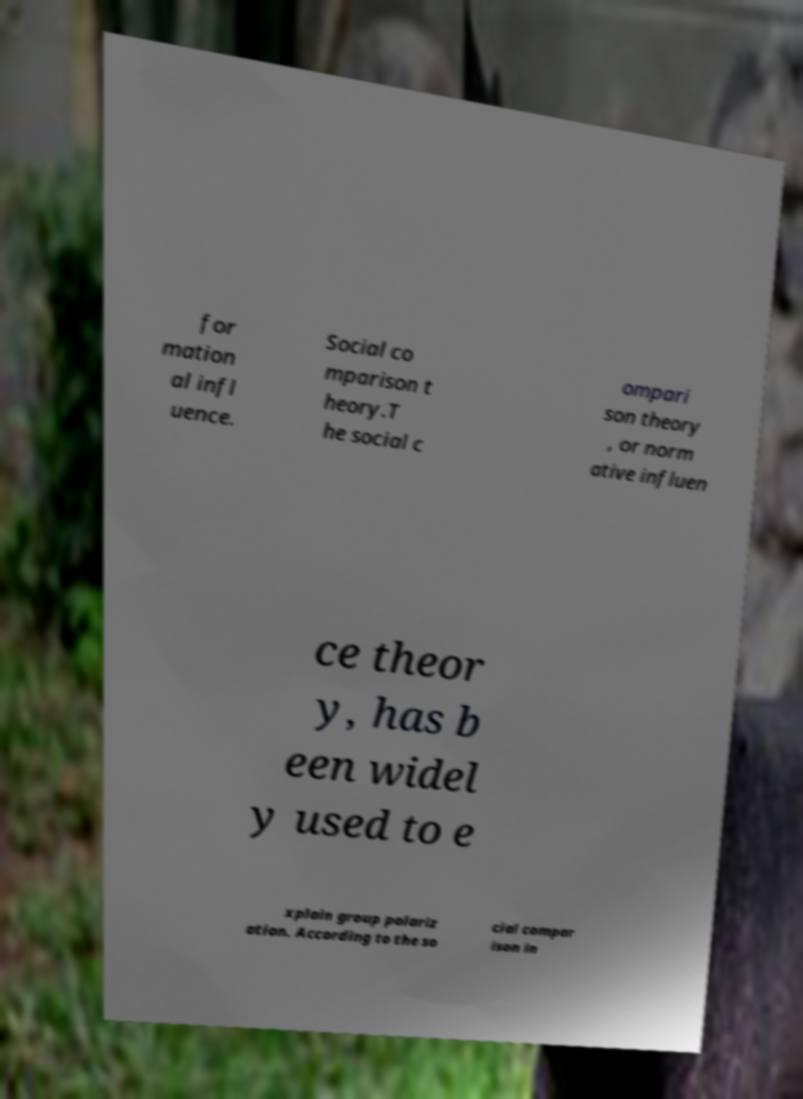What messages or text are displayed in this image? I need them in a readable, typed format. for mation al infl uence. Social co mparison t heory.T he social c ompari son theory , or norm ative influen ce theor y, has b een widel y used to e xplain group polariz ation. According to the so cial compar ison in 